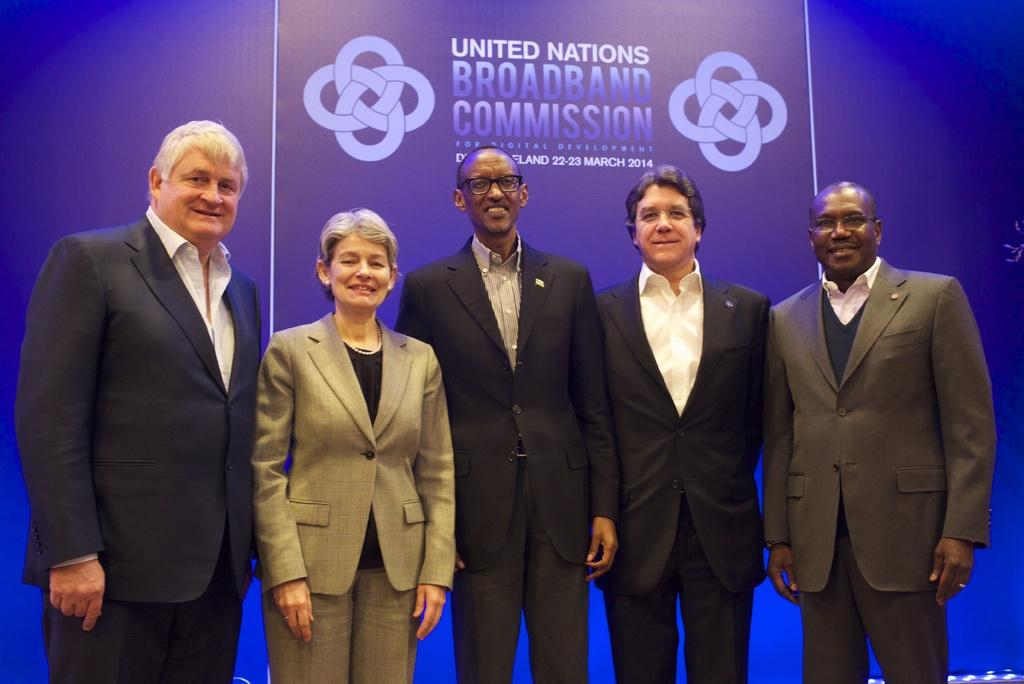What are the persons in the image wearing? The persons in the image are wearing suits. What are the persons in the image doing? The persons are standing. What can be seen hanging or displayed in the image? There is a banner in the image. What is written or displayed on the banner? The banner has something written on it. What advice is given by the wealth in the image? There is no mention of wealth or advice in the image; it features persons wearing suits and a banner with writing. 